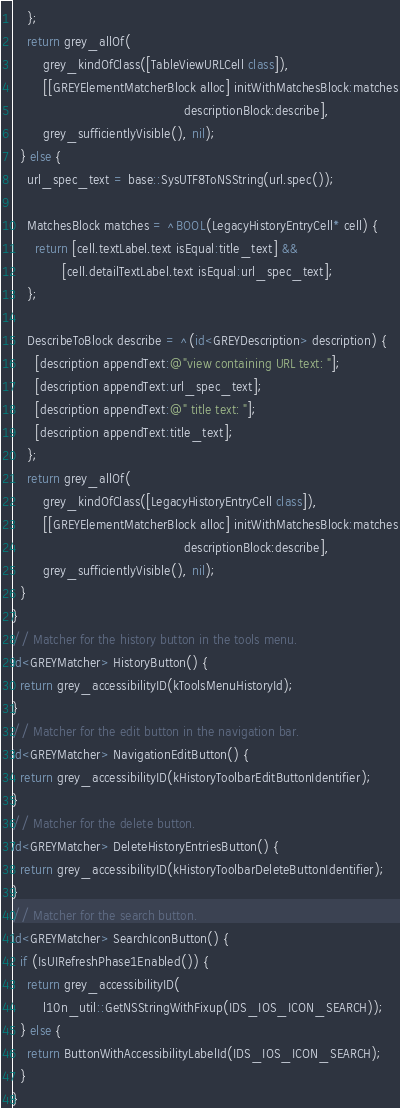Convert code to text. <code><loc_0><loc_0><loc_500><loc_500><_ObjectiveC_>    };
    return grey_allOf(
        grey_kindOfClass([TableViewURLCell class]),
        [[GREYElementMatcherBlock alloc] initWithMatchesBlock:matches
                                             descriptionBlock:describe],
        grey_sufficientlyVisible(), nil);
  } else {
    url_spec_text = base::SysUTF8ToNSString(url.spec());

    MatchesBlock matches = ^BOOL(LegacyHistoryEntryCell* cell) {
      return [cell.textLabel.text isEqual:title_text] &&
             [cell.detailTextLabel.text isEqual:url_spec_text];
    };

    DescribeToBlock describe = ^(id<GREYDescription> description) {
      [description appendText:@"view containing URL text: "];
      [description appendText:url_spec_text];
      [description appendText:@" title text: "];
      [description appendText:title_text];
    };
    return grey_allOf(
        grey_kindOfClass([LegacyHistoryEntryCell class]),
        [[GREYElementMatcherBlock alloc] initWithMatchesBlock:matches
                                             descriptionBlock:describe],
        grey_sufficientlyVisible(), nil);
  }
}
// Matcher for the history button in the tools menu.
id<GREYMatcher> HistoryButton() {
  return grey_accessibilityID(kToolsMenuHistoryId);
}
// Matcher for the edit button in the navigation bar.
id<GREYMatcher> NavigationEditButton() {
  return grey_accessibilityID(kHistoryToolbarEditButtonIdentifier);
}
// Matcher for the delete button.
id<GREYMatcher> DeleteHistoryEntriesButton() {
  return grey_accessibilityID(kHistoryToolbarDeleteButtonIdentifier);
}
// Matcher for the search button.
id<GREYMatcher> SearchIconButton() {
  if (IsUIRefreshPhase1Enabled()) {
    return grey_accessibilityID(
        l10n_util::GetNSStringWithFixup(IDS_IOS_ICON_SEARCH));
  } else {
    return ButtonWithAccessibilityLabelId(IDS_IOS_ICON_SEARCH);
  }
}</code> 